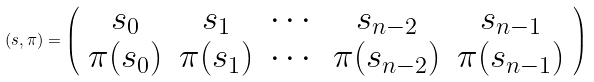Convert formula to latex. <formula><loc_0><loc_0><loc_500><loc_500>( s , \pi ) = \left ( \begin{array} { c c c c c } s _ { 0 } & s _ { 1 } & \cdots & s _ { n - 2 } & s _ { n - 1 } \\ \pi ( s _ { 0 } ) & \pi ( s _ { 1 } ) & \cdots & \pi ( s _ { n - 2 } ) & \pi ( s _ { n - 1 } ) \end{array} \right )</formula> 